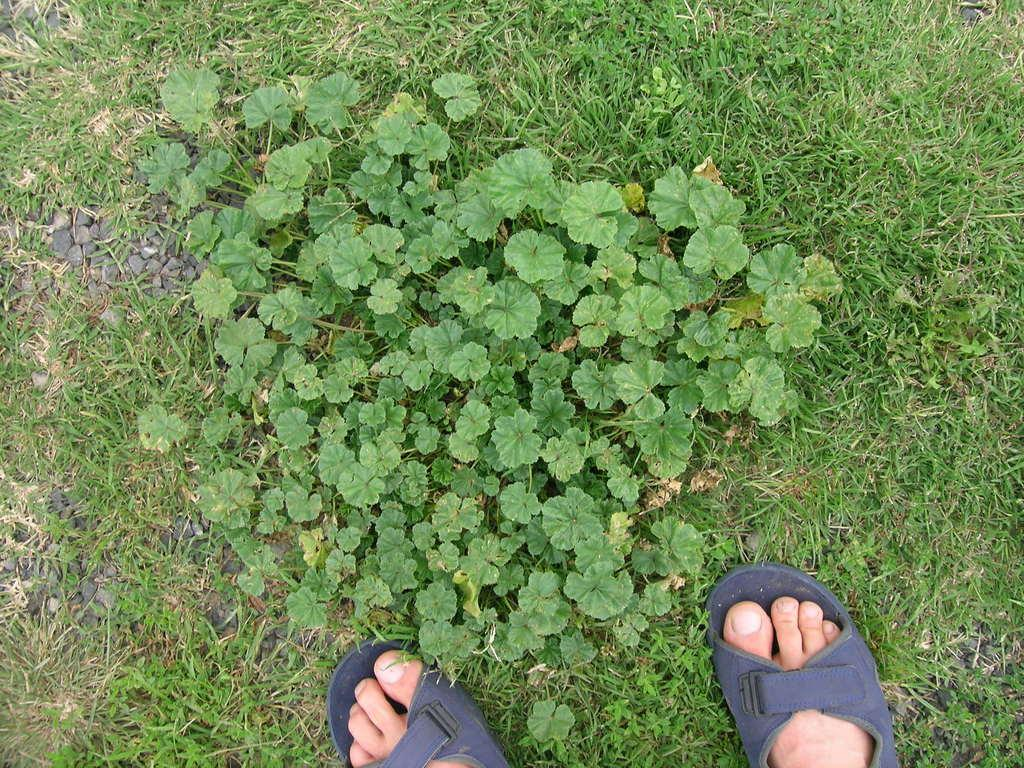What body parts of people are visible in the image? There are persons' legs visible in the image. What type of natural environment is visible in the image? There is grass visible in the image. What book is being read by the sisters during their lunch in the image? There is no reference to a book, reading, lunch, or sisters in the image, so it is not possible to answer that question. 